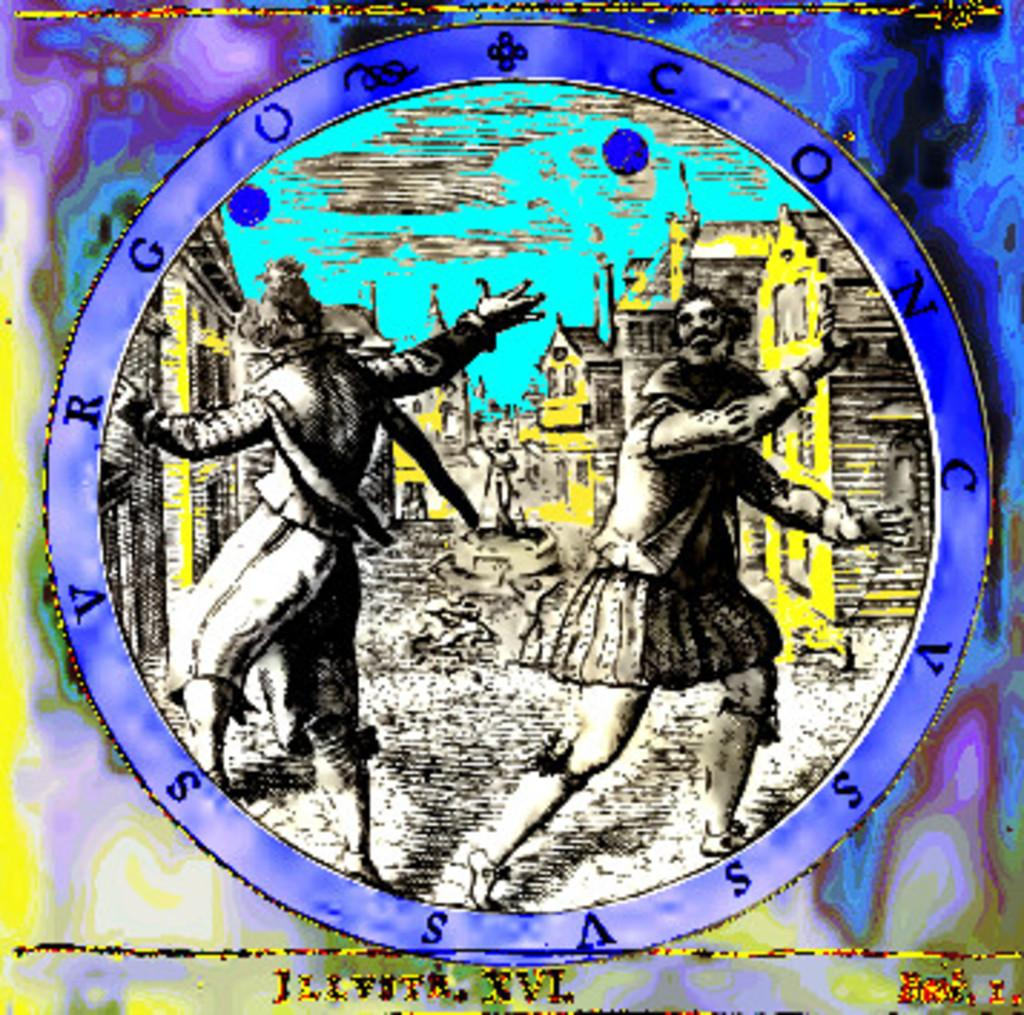How many people are visible in the image? There are two persons standing in the front of the image. What can be seen in the background of the image? There are yellow color buildings in the background of the image. What type of shirt is the servant wearing in the image? There is no servant present in the image, and therefore no shirt can be described. 